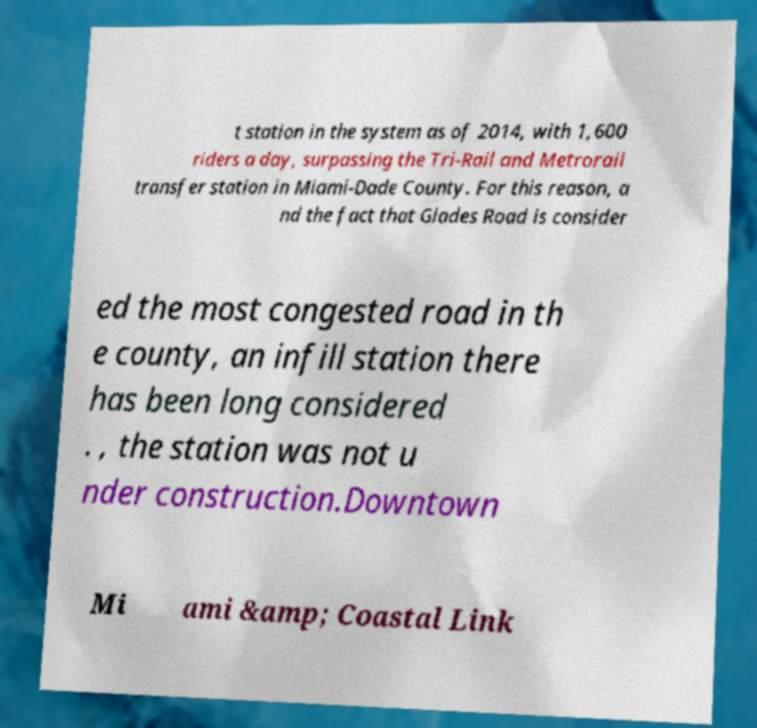Can you accurately transcribe the text from the provided image for me? t station in the system as of 2014, with 1,600 riders a day, surpassing the Tri-Rail and Metrorail transfer station in Miami-Dade County. For this reason, a nd the fact that Glades Road is consider ed the most congested road in th e county, an infill station there has been long considered . , the station was not u nder construction.Downtown Mi ami &amp; Coastal Link 